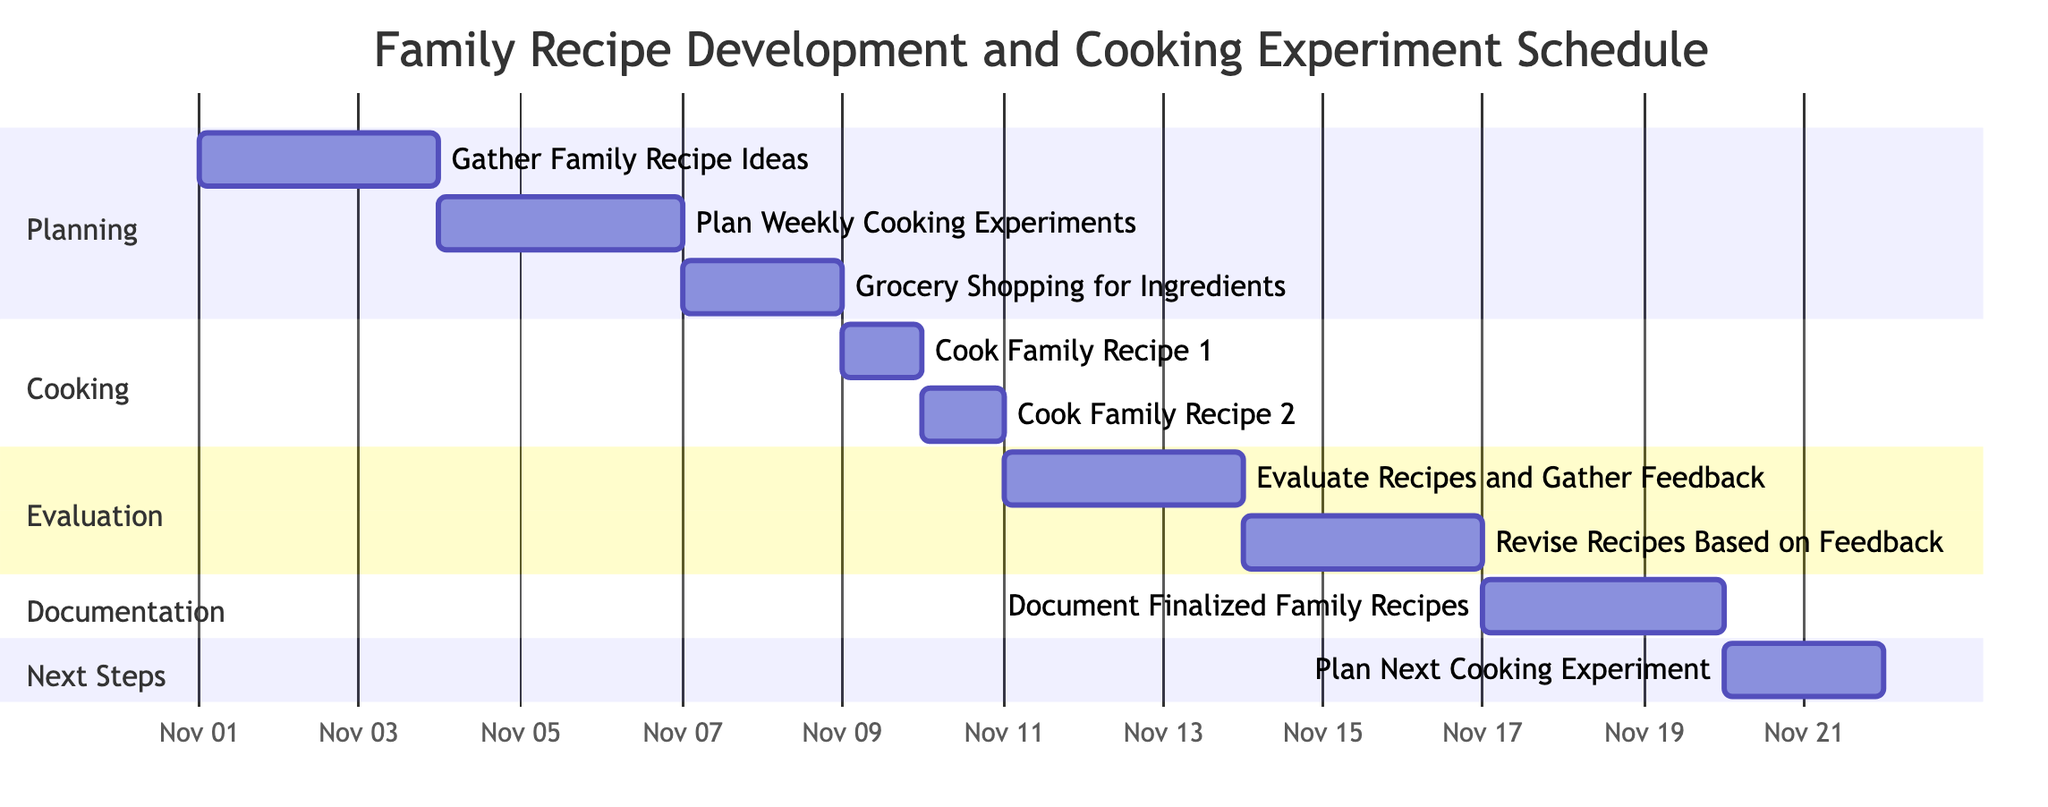What is the duration of the task “Cook Family Recipe 2: Aunt Lisa's Lasagna”? The task “Cook Family Recipe 2: Aunt Lisa's Lasagna” has a specified duration of 1 day in the Gantt chart.
Answer: 1 day How many tasks are scheduled in the “Cooking” section? There are two tasks listed in the “Cooking” section: “Cook Family Recipe 1: Grandma's Chicken Soup” and “Cook Family Recipe 2: Aunt Lisa's Lasagna.” Therefore, the total count of tasks is two.
Answer: 2 What is the start date for the task “Evaluate Recipes and Gather Feedback”? The start date for the task “Evaluate Recipes and Gather Feedback” is shown as November 11, 2023, in the Gantt chart.
Answer: November 11, 2023 Which task occurs immediately after "Grocery Shopping for Ingredients"? The task that occurs immediately after "Grocery Shopping for Ingredients" is "Cook Family Recipe 1: Grandma's Chicken Soup," which starts immediately after the conclusion of grocery shopping.
Answer: Cook Family Recipe 1: Grandma's Chicken Soup What is the timeline span from the beginning of “Gather Family Recipe Ideas” to the end of “Document Finalized Family Recipes”? The timeline begins on November 1, 2023, with the task “Gather Family Recipe Ideas” and extends until November 19, 2023, when the task “Document Finalized Family Recipes” ends, covering a duration of 19 days in total.
Answer: 19 days How many days are allocated for evaluating recipes? The task titled “Evaluate Recipes and Gather Feedback” is allocated a duration of 3 days, which directly indicates how much time has been set aside for the evaluation stage.
Answer: 3 days Which task has the latest start date in the schedule? The task with the latest start date is “Plan Next Cooking Experiment,” which begins on November 20, 2023, making it the last task to initiate in the given schedule.
Answer: Plan Next Cooking Experiment What is the total duration of the "Planning" section? In the "Planning" section, "Gather Family Recipe Ideas" has a duration of 3 days, "Plan Weekly Cooking Experiments" has 3 days, and "Grocery Shopping for Ingredients" has 2 days, resulting in a total duration of 8 days when summed together.
Answer: 8 days What task comes right before “Revise Recipes Based on Feedback”? The task that comes right before “Revise Recipes Based on Feedback” is “Evaluate Recipes and Gather Feedback,” which directly precedes it in the sequence shown on the Gantt chart.
Answer: Evaluate Recipes and Gather Feedback 